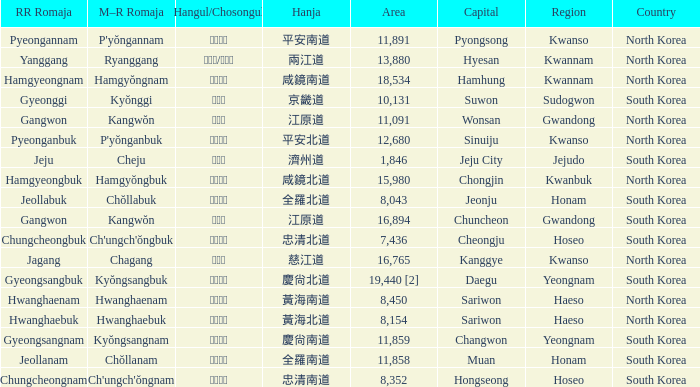Which capital has a Hangul of 경상남도? Changwon. 